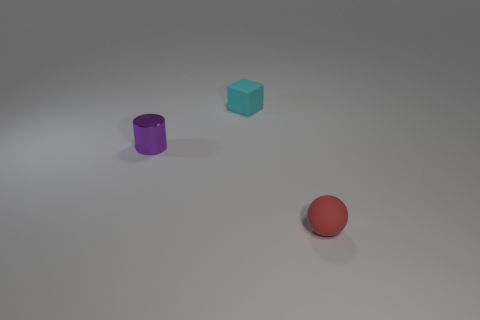Is the tiny purple object made of the same material as the tiny cyan block?
Ensure brevity in your answer.  No. There is a tiny purple thing; are there any tiny shiny things on the left side of it?
Your answer should be very brief. No. There is a small object behind the small purple shiny cylinder that is in front of the tiny matte block; what is it made of?
Make the answer very short. Rubber. Is the color of the cube the same as the small cylinder?
Your response must be concise. No. The small object that is both in front of the cyan cube and right of the purple cylinder is what color?
Provide a short and direct response. Red. Do the thing left of the cyan matte object and the small matte cube have the same size?
Give a very brief answer. Yes. Are there any other things that are the same shape as the red object?
Keep it short and to the point. No. Are the red sphere and the object that is behind the small purple metal object made of the same material?
Provide a short and direct response. Yes. What number of yellow things are either rubber spheres or cylinders?
Give a very brief answer. 0. Are any red rubber things visible?
Your answer should be very brief. Yes. 